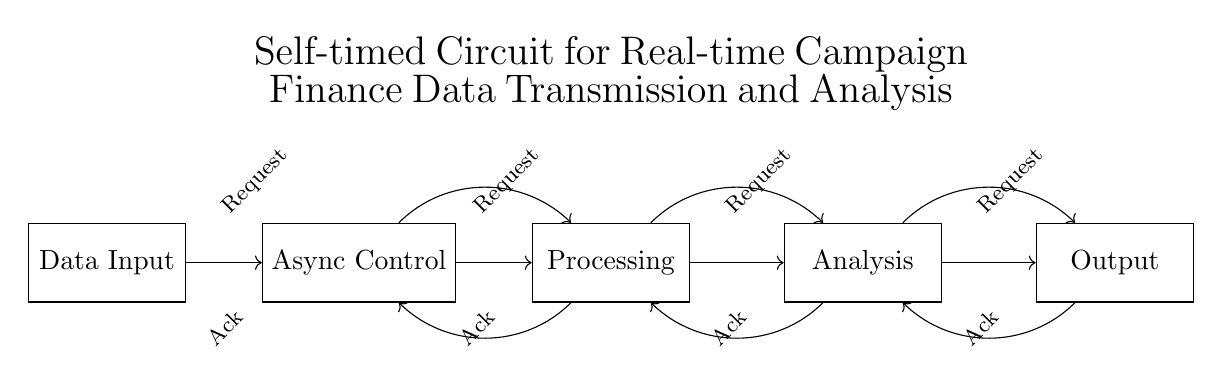What is the first component in the circuit? The first component is the Data Input, which is the starting point of the circuit in the flow of data.
Answer: Data Input How many main components are in this circuit? The circuit contains five main components: Data Input, Async Control, Processing, Analysis, and Output.
Answer: Five What type of control does this circuit use? The circuit uses Asynchronous Control, which allows different parts of the circuit to operate independently rather than in a synchronous manner.
Answer: Asynchronous What is the purpose of the feedback loops in this circuit? The feedback loops provide completion signals, allowing stages of the circuit to communicate and ensure data processing continues correctly.
Answer: Completion signals Which component follows the Async Control in data flow? The Processing component follows the Async Control, signifying that after control signals, data is processed.
Answer: Processing What is the direction of data flow in the circuit? The data flows from left to right, starting at the Data Input and moving sequentially through each component to the Output.
Answer: Left to right 